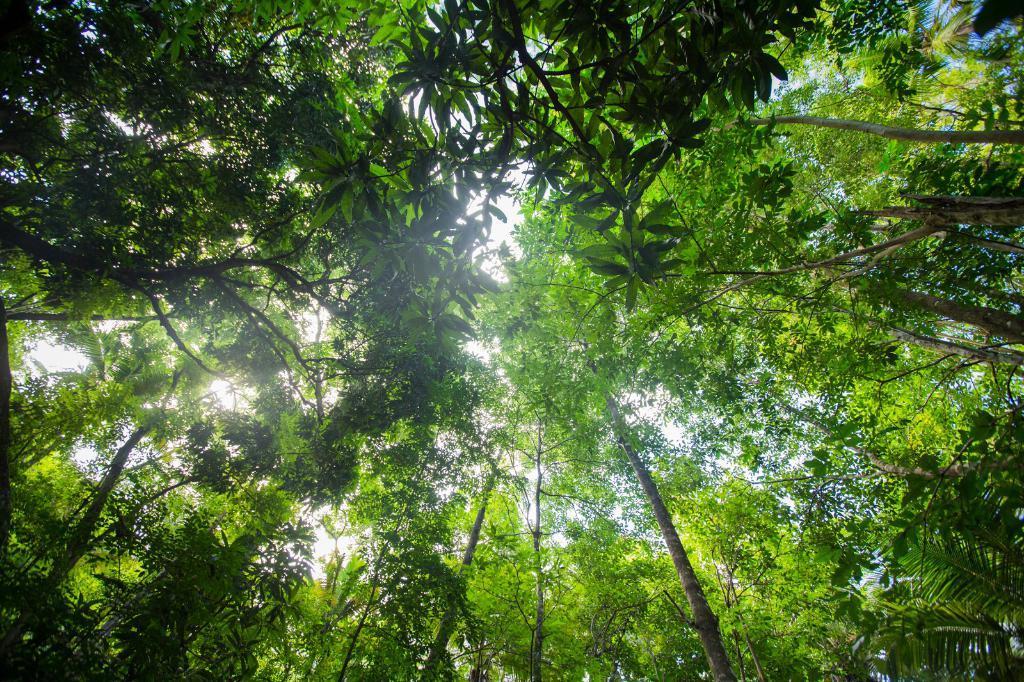Can you describe this image briefly? This picture is taken from outside of the city. In this image, we can see some trees. In the background, we can see a sky. 